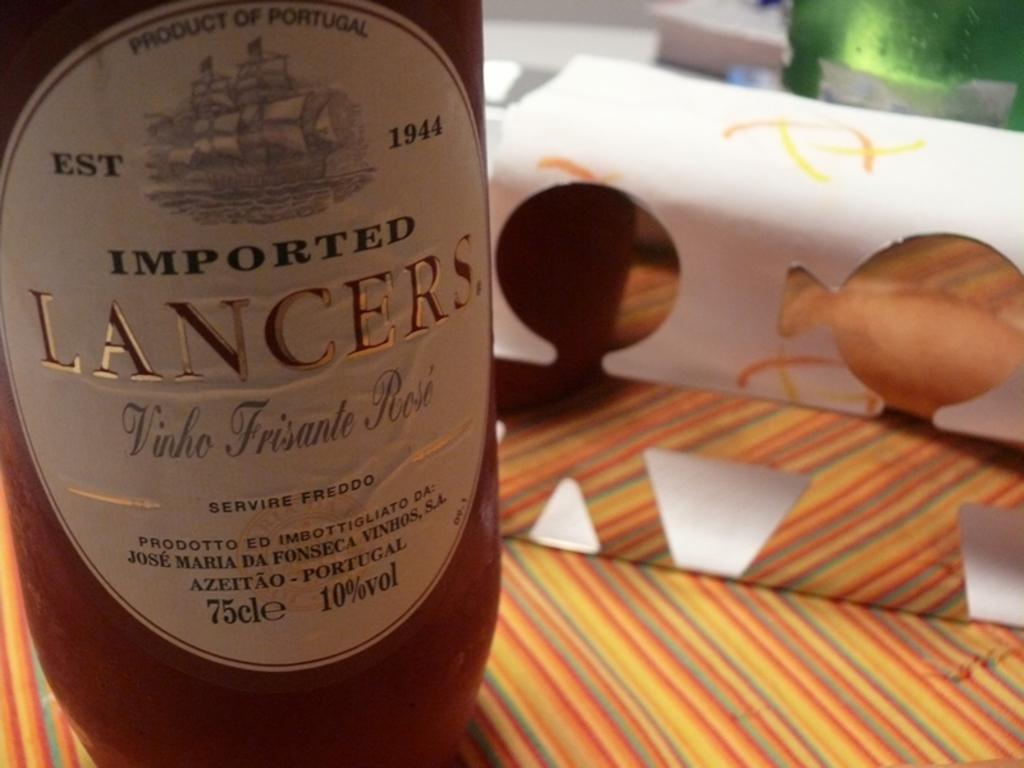What type of bottle is present in the image? There is an imported Lancers bottle in the image. Where is the bottle located? The bottle is placed on a table. Can you describe the position of the table in the image? The table is located at the left side of the image. How many friends are in jail with the bottle in the image? There are no friends or jails present in the image; it only features an imported Lancers bottle on a table. 